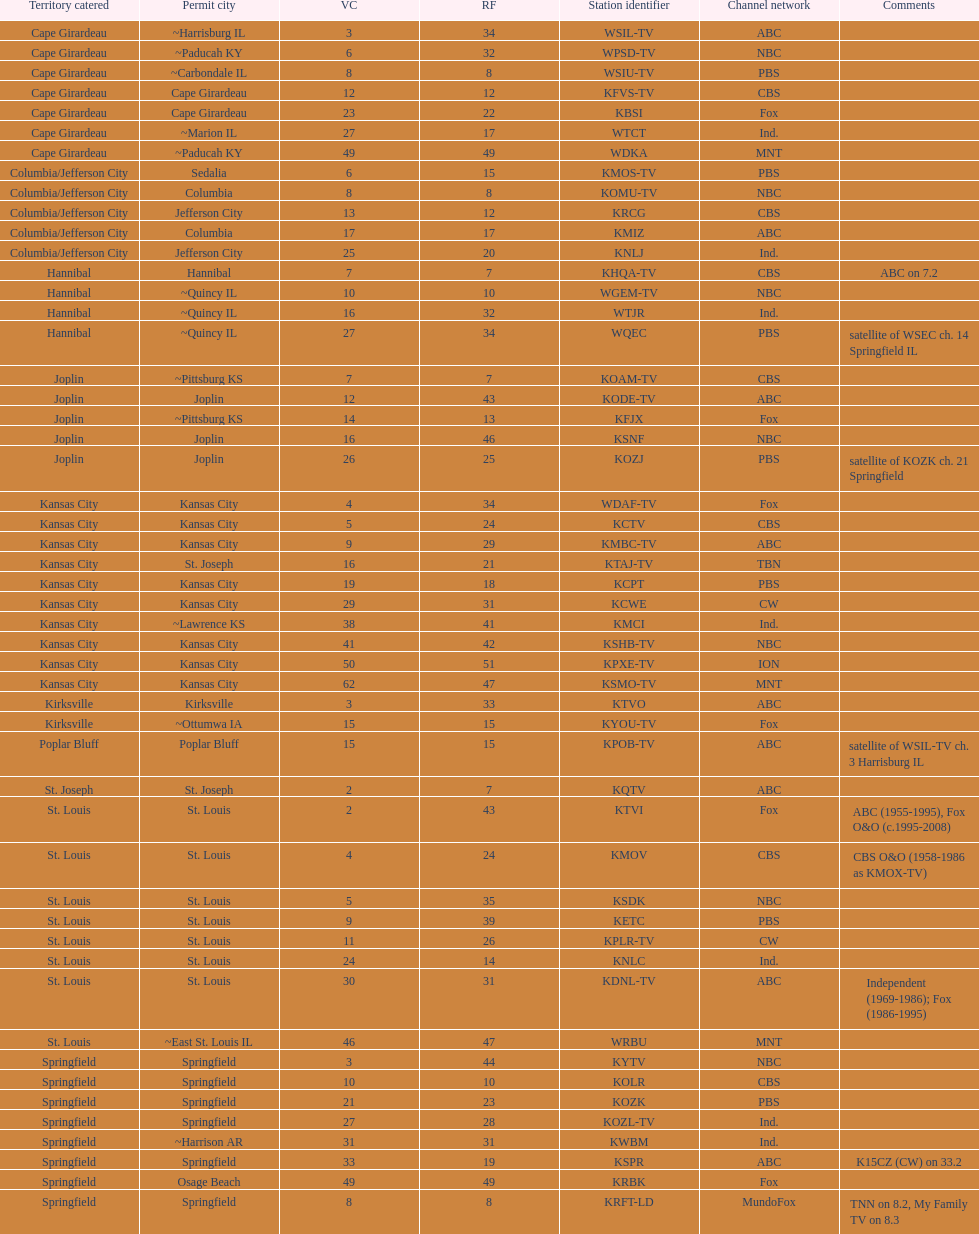Could you parse the entire table as a dict? {'header': ['Territory catered', 'Permit city', 'VC', 'RF', 'Station identifier', 'Channel network', 'Comments'], 'rows': [['Cape Girardeau', '~Harrisburg IL', '3', '34', 'WSIL-TV', 'ABC', ''], ['Cape Girardeau', '~Paducah KY', '6', '32', 'WPSD-TV', 'NBC', ''], ['Cape Girardeau', '~Carbondale IL', '8', '8', 'WSIU-TV', 'PBS', ''], ['Cape Girardeau', 'Cape Girardeau', '12', '12', 'KFVS-TV', 'CBS', ''], ['Cape Girardeau', 'Cape Girardeau', '23', '22', 'KBSI', 'Fox', ''], ['Cape Girardeau', '~Marion IL', '27', '17', 'WTCT', 'Ind.', ''], ['Cape Girardeau', '~Paducah KY', '49', '49', 'WDKA', 'MNT', ''], ['Columbia/Jefferson City', 'Sedalia', '6', '15', 'KMOS-TV', 'PBS', ''], ['Columbia/Jefferson City', 'Columbia', '8', '8', 'KOMU-TV', 'NBC', ''], ['Columbia/Jefferson City', 'Jefferson City', '13', '12', 'KRCG', 'CBS', ''], ['Columbia/Jefferson City', 'Columbia', '17', '17', 'KMIZ', 'ABC', ''], ['Columbia/Jefferson City', 'Jefferson City', '25', '20', 'KNLJ', 'Ind.', ''], ['Hannibal', 'Hannibal', '7', '7', 'KHQA-TV', 'CBS', 'ABC on 7.2'], ['Hannibal', '~Quincy IL', '10', '10', 'WGEM-TV', 'NBC', ''], ['Hannibal', '~Quincy IL', '16', '32', 'WTJR', 'Ind.', ''], ['Hannibal', '~Quincy IL', '27', '34', 'WQEC', 'PBS', 'satellite of WSEC ch. 14 Springfield IL'], ['Joplin', '~Pittsburg KS', '7', '7', 'KOAM-TV', 'CBS', ''], ['Joplin', 'Joplin', '12', '43', 'KODE-TV', 'ABC', ''], ['Joplin', '~Pittsburg KS', '14', '13', 'KFJX', 'Fox', ''], ['Joplin', 'Joplin', '16', '46', 'KSNF', 'NBC', ''], ['Joplin', 'Joplin', '26', '25', 'KOZJ', 'PBS', 'satellite of KOZK ch. 21 Springfield'], ['Kansas City', 'Kansas City', '4', '34', 'WDAF-TV', 'Fox', ''], ['Kansas City', 'Kansas City', '5', '24', 'KCTV', 'CBS', ''], ['Kansas City', 'Kansas City', '9', '29', 'KMBC-TV', 'ABC', ''], ['Kansas City', 'St. Joseph', '16', '21', 'KTAJ-TV', 'TBN', ''], ['Kansas City', 'Kansas City', '19', '18', 'KCPT', 'PBS', ''], ['Kansas City', 'Kansas City', '29', '31', 'KCWE', 'CW', ''], ['Kansas City', '~Lawrence KS', '38', '41', 'KMCI', 'Ind.', ''], ['Kansas City', 'Kansas City', '41', '42', 'KSHB-TV', 'NBC', ''], ['Kansas City', 'Kansas City', '50', '51', 'KPXE-TV', 'ION', ''], ['Kansas City', 'Kansas City', '62', '47', 'KSMO-TV', 'MNT', ''], ['Kirksville', 'Kirksville', '3', '33', 'KTVO', 'ABC', ''], ['Kirksville', '~Ottumwa IA', '15', '15', 'KYOU-TV', 'Fox', ''], ['Poplar Bluff', 'Poplar Bluff', '15', '15', 'KPOB-TV', 'ABC', 'satellite of WSIL-TV ch. 3 Harrisburg IL'], ['St. Joseph', 'St. Joseph', '2', '7', 'KQTV', 'ABC', ''], ['St. Louis', 'St. Louis', '2', '43', 'KTVI', 'Fox', 'ABC (1955-1995), Fox O&O (c.1995-2008)'], ['St. Louis', 'St. Louis', '4', '24', 'KMOV', 'CBS', 'CBS O&O (1958-1986 as KMOX-TV)'], ['St. Louis', 'St. Louis', '5', '35', 'KSDK', 'NBC', ''], ['St. Louis', 'St. Louis', '9', '39', 'KETC', 'PBS', ''], ['St. Louis', 'St. Louis', '11', '26', 'KPLR-TV', 'CW', ''], ['St. Louis', 'St. Louis', '24', '14', 'KNLC', 'Ind.', ''], ['St. Louis', 'St. Louis', '30', '31', 'KDNL-TV', 'ABC', 'Independent (1969-1986); Fox (1986-1995)'], ['St. Louis', '~East St. Louis IL', '46', '47', 'WRBU', 'MNT', ''], ['Springfield', 'Springfield', '3', '44', 'KYTV', 'NBC', ''], ['Springfield', 'Springfield', '10', '10', 'KOLR', 'CBS', ''], ['Springfield', 'Springfield', '21', '23', 'KOZK', 'PBS', ''], ['Springfield', 'Springfield', '27', '28', 'KOZL-TV', 'Ind.', ''], ['Springfield', '~Harrison AR', '31', '31', 'KWBM', 'Ind.', ''], ['Springfield', 'Springfield', '33', '19', 'KSPR', 'ABC', 'K15CZ (CW) on 33.2'], ['Springfield', 'Osage Beach', '49', '49', 'KRBK', 'Fox', ''], ['Springfield', 'Springfield', '8', '8', 'KRFT-LD', 'MundoFox', 'TNN on 8.2, My Family TV on 8.3']]} Which station is licensed in the same city as koam-tv? KFJX. 